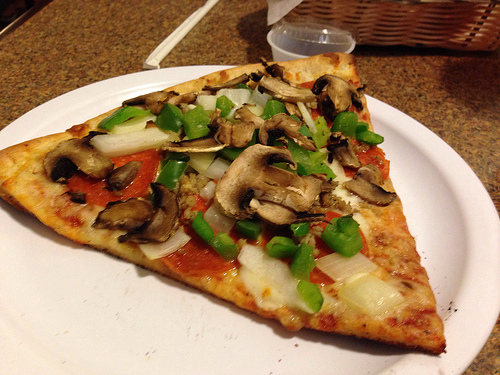Please provide a short description for this region: [0.63, 0.61, 0.81, 0.77]. This area of the image features onions atop pepperoni pizza. 